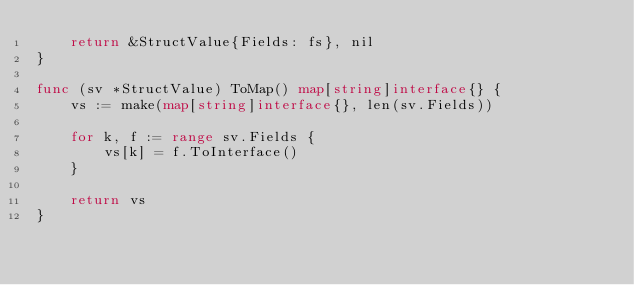Convert code to text. <code><loc_0><loc_0><loc_500><loc_500><_Go_>	return &StructValue{Fields: fs}, nil
}

func (sv *StructValue) ToMap() map[string]interface{} {
	vs := make(map[string]interface{}, len(sv.Fields))

	for k, f := range sv.Fields {
		vs[k] = f.ToInterface()
	}

	return vs
}
</code> 